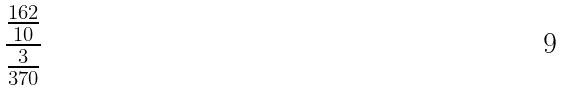Convert formula to latex. <formula><loc_0><loc_0><loc_500><loc_500>\frac { \frac { 1 6 2 } { 1 0 } } { \frac { 3 } { 3 7 0 } }</formula> 